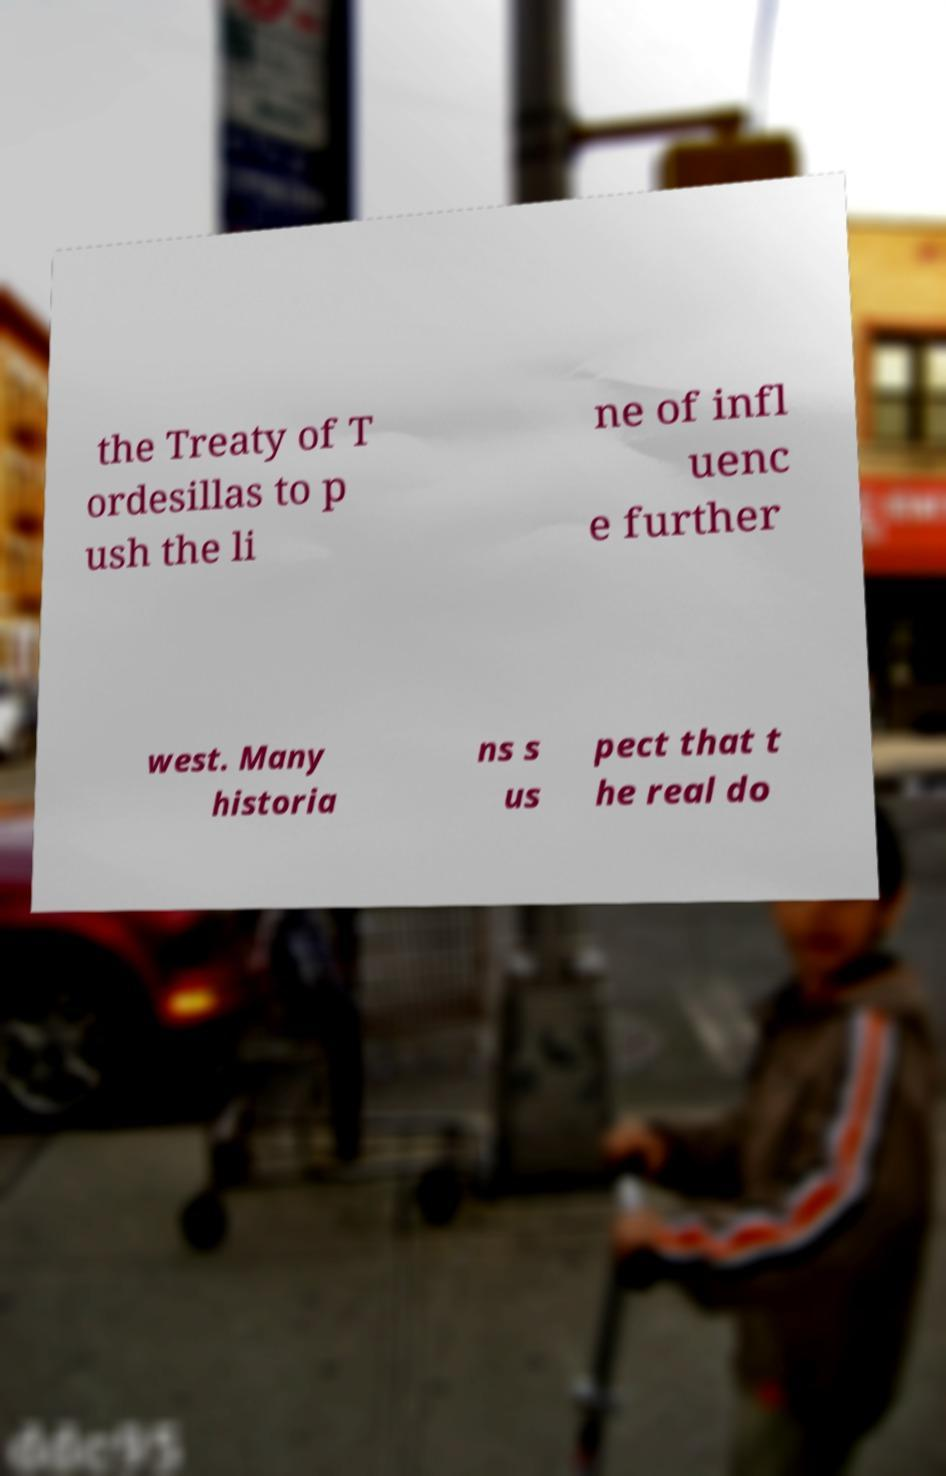For documentation purposes, I need the text within this image transcribed. Could you provide that? the Treaty of T ordesillas to p ush the li ne of infl uenc e further west. Many historia ns s us pect that t he real do 